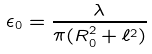Convert formula to latex. <formula><loc_0><loc_0><loc_500><loc_500>\epsilon _ { 0 } = \frac { \lambda } { \pi ( R _ { 0 } ^ { 2 } + \ell ^ { 2 } ) }</formula> 